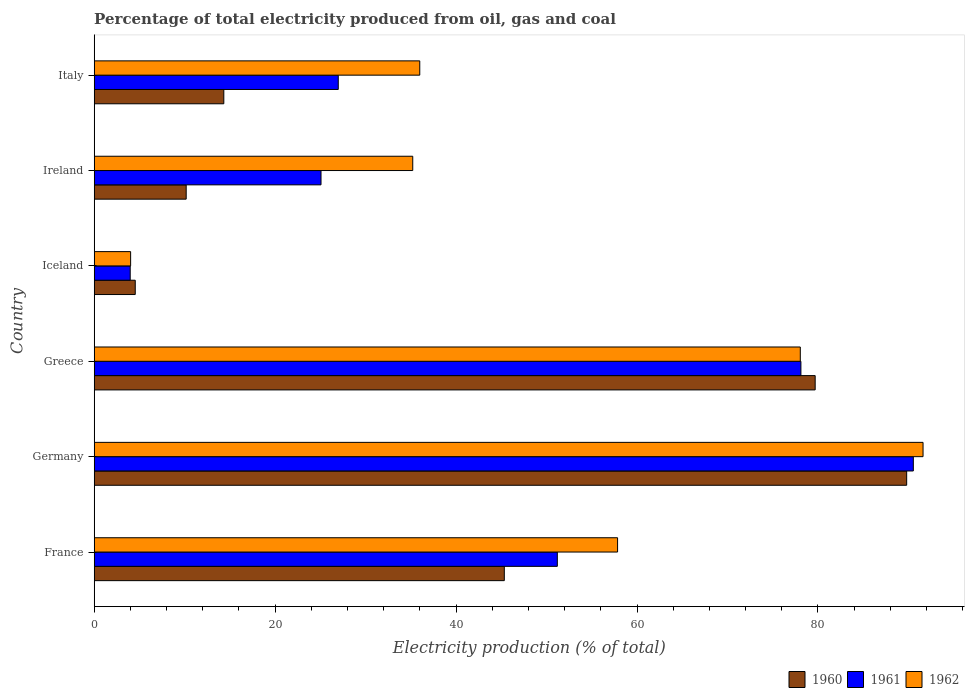How many groups of bars are there?
Keep it short and to the point. 6. Are the number of bars on each tick of the Y-axis equal?
Provide a short and direct response. Yes. How many bars are there on the 5th tick from the top?
Give a very brief answer. 3. How many bars are there on the 6th tick from the bottom?
Your response must be concise. 3. What is the label of the 1st group of bars from the top?
Your answer should be very brief. Italy. What is the electricity production in in 1962 in Ireland?
Provide a succinct answer. 35.21. Across all countries, what is the maximum electricity production in in 1961?
Provide a short and direct response. 90.54. Across all countries, what is the minimum electricity production in in 1961?
Your response must be concise. 3.98. In which country was the electricity production in in 1962 maximum?
Ensure brevity in your answer.  Germany. What is the total electricity production in in 1962 in the graph?
Your response must be concise. 302.74. What is the difference between the electricity production in in 1961 in France and that in Germany?
Keep it short and to the point. -39.35. What is the difference between the electricity production in in 1962 in Ireland and the electricity production in in 1961 in Germany?
Offer a terse response. -55.33. What is the average electricity production in in 1961 per country?
Provide a short and direct response. 45.98. What is the difference between the electricity production in in 1962 and electricity production in in 1960 in Iceland?
Your response must be concise. -0.51. In how many countries, is the electricity production in in 1962 greater than 52 %?
Your answer should be compact. 3. What is the ratio of the electricity production in in 1960 in France to that in Iceland?
Keep it short and to the point. 9.99. What is the difference between the highest and the second highest electricity production in in 1960?
Provide a succinct answer. 10.11. What is the difference between the highest and the lowest electricity production in in 1961?
Offer a terse response. 86.56. In how many countries, is the electricity production in in 1961 greater than the average electricity production in in 1961 taken over all countries?
Offer a very short reply. 3. Is it the case that in every country, the sum of the electricity production in in 1961 and electricity production in in 1962 is greater than the electricity production in in 1960?
Your response must be concise. Yes. Are all the bars in the graph horizontal?
Keep it short and to the point. Yes. What is the difference between two consecutive major ticks on the X-axis?
Ensure brevity in your answer.  20. Does the graph contain any zero values?
Offer a terse response. No. Where does the legend appear in the graph?
Provide a short and direct response. Bottom right. How many legend labels are there?
Provide a succinct answer. 3. What is the title of the graph?
Your answer should be compact. Percentage of total electricity produced from oil, gas and coal. Does "2005" appear as one of the legend labels in the graph?
Keep it short and to the point. No. What is the label or title of the X-axis?
Your answer should be very brief. Electricity production (% of total). What is the Electricity production (% of total) in 1960 in France?
Keep it short and to the point. 45.33. What is the Electricity production (% of total) in 1961 in France?
Your answer should be very brief. 51.19. What is the Electricity production (% of total) of 1962 in France?
Make the answer very short. 57.85. What is the Electricity production (% of total) of 1960 in Germany?
Offer a terse response. 89.81. What is the Electricity production (% of total) in 1961 in Germany?
Your response must be concise. 90.54. What is the Electricity production (% of total) in 1962 in Germany?
Keep it short and to the point. 91.62. What is the Electricity production (% of total) of 1960 in Greece?
Make the answer very short. 79.69. What is the Electricity production (% of total) in 1961 in Greece?
Give a very brief answer. 78.12. What is the Electricity production (% of total) of 1962 in Greece?
Provide a succinct answer. 78.05. What is the Electricity production (% of total) of 1960 in Iceland?
Offer a terse response. 4.54. What is the Electricity production (% of total) of 1961 in Iceland?
Make the answer very short. 3.98. What is the Electricity production (% of total) of 1962 in Iceland?
Provide a succinct answer. 4.03. What is the Electricity production (% of total) in 1960 in Ireland?
Offer a terse response. 10.17. What is the Electricity production (% of total) of 1961 in Ireland?
Provide a succinct answer. 25.07. What is the Electricity production (% of total) in 1962 in Ireland?
Provide a short and direct response. 35.21. What is the Electricity production (% of total) of 1960 in Italy?
Ensure brevity in your answer.  14.33. What is the Electricity production (% of total) of 1961 in Italy?
Offer a very short reply. 26.98. What is the Electricity production (% of total) in 1962 in Italy?
Your answer should be very brief. 35.99. Across all countries, what is the maximum Electricity production (% of total) in 1960?
Make the answer very short. 89.81. Across all countries, what is the maximum Electricity production (% of total) of 1961?
Offer a very short reply. 90.54. Across all countries, what is the maximum Electricity production (% of total) in 1962?
Give a very brief answer. 91.62. Across all countries, what is the minimum Electricity production (% of total) of 1960?
Your answer should be compact. 4.54. Across all countries, what is the minimum Electricity production (% of total) of 1961?
Provide a succinct answer. 3.98. Across all countries, what is the minimum Electricity production (% of total) of 1962?
Offer a terse response. 4.03. What is the total Electricity production (% of total) of 1960 in the graph?
Your answer should be compact. 243.87. What is the total Electricity production (% of total) in 1961 in the graph?
Give a very brief answer. 275.88. What is the total Electricity production (% of total) of 1962 in the graph?
Provide a short and direct response. 302.74. What is the difference between the Electricity production (% of total) in 1960 in France and that in Germany?
Keep it short and to the point. -44.48. What is the difference between the Electricity production (% of total) in 1961 in France and that in Germany?
Your response must be concise. -39.35. What is the difference between the Electricity production (% of total) of 1962 in France and that in Germany?
Your answer should be very brief. -33.77. What is the difference between the Electricity production (% of total) of 1960 in France and that in Greece?
Provide a succinct answer. -34.36. What is the difference between the Electricity production (% of total) of 1961 in France and that in Greece?
Give a very brief answer. -26.92. What is the difference between the Electricity production (% of total) of 1962 in France and that in Greece?
Provide a short and direct response. -20.2. What is the difference between the Electricity production (% of total) in 1960 in France and that in Iceland?
Provide a succinct answer. 40.8. What is the difference between the Electricity production (% of total) of 1961 in France and that in Iceland?
Your response must be concise. 47.21. What is the difference between the Electricity production (% of total) in 1962 in France and that in Iceland?
Your answer should be very brief. 53.83. What is the difference between the Electricity production (% of total) in 1960 in France and that in Ireland?
Your response must be concise. 35.16. What is the difference between the Electricity production (% of total) in 1961 in France and that in Ireland?
Ensure brevity in your answer.  26.12. What is the difference between the Electricity production (% of total) of 1962 in France and that in Ireland?
Offer a terse response. 22.64. What is the difference between the Electricity production (% of total) of 1960 in France and that in Italy?
Offer a very short reply. 31. What is the difference between the Electricity production (% of total) of 1961 in France and that in Italy?
Give a very brief answer. 24.21. What is the difference between the Electricity production (% of total) in 1962 in France and that in Italy?
Offer a very short reply. 21.86. What is the difference between the Electricity production (% of total) in 1960 in Germany and that in Greece?
Provide a succinct answer. 10.11. What is the difference between the Electricity production (% of total) in 1961 in Germany and that in Greece?
Offer a very short reply. 12.43. What is the difference between the Electricity production (% of total) of 1962 in Germany and that in Greece?
Your answer should be very brief. 13.57. What is the difference between the Electricity production (% of total) in 1960 in Germany and that in Iceland?
Your response must be concise. 85.27. What is the difference between the Electricity production (% of total) of 1961 in Germany and that in Iceland?
Keep it short and to the point. 86.56. What is the difference between the Electricity production (% of total) of 1962 in Germany and that in Iceland?
Make the answer very short. 87.59. What is the difference between the Electricity production (% of total) in 1960 in Germany and that in Ireland?
Give a very brief answer. 79.64. What is the difference between the Electricity production (% of total) in 1961 in Germany and that in Ireland?
Your answer should be very brief. 65.47. What is the difference between the Electricity production (% of total) in 1962 in Germany and that in Ireland?
Your answer should be very brief. 56.41. What is the difference between the Electricity production (% of total) of 1960 in Germany and that in Italy?
Make the answer very short. 75.48. What is the difference between the Electricity production (% of total) of 1961 in Germany and that in Italy?
Offer a terse response. 63.57. What is the difference between the Electricity production (% of total) of 1962 in Germany and that in Italy?
Give a very brief answer. 55.63. What is the difference between the Electricity production (% of total) of 1960 in Greece and that in Iceland?
Your answer should be very brief. 75.16. What is the difference between the Electricity production (% of total) in 1961 in Greece and that in Iceland?
Offer a terse response. 74.14. What is the difference between the Electricity production (% of total) in 1962 in Greece and that in Iceland?
Offer a very short reply. 74.02. What is the difference between the Electricity production (% of total) of 1960 in Greece and that in Ireland?
Offer a very short reply. 69.53. What is the difference between the Electricity production (% of total) in 1961 in Greece and that in Ireland?
Your response must be concise. 53.05. What is the difference between the Electricity production (% of total) in 1962 in Greece and that in Ireland?
Your answer should be compact. 42.84. What is the difference between the Electricity production (% of total) of 1960 in Greece and that in Italy?
Your response must be concise. 65.37. What is the difference between the Electricity production (% of total) in 1961 in Greece and that in Italy?
Your answer should be compact. 51.14. What is the difference between the Electricity production (% of total) in 1962 in Greece and that in Italy?
Give a very brief answer. 42.06. What is the difference between the Electricity production (% of total) in 1960 in Iceland and that in Ireland?
Make the answer very short. -5.63. What is the difference between the Electricity production (% of total) in 1961 in Iceland and that in Ireland?
Provide a succinct answer. -21.09. What is the difference between the Electricity production (% of total) of 1962 in Iceland and that in Ireland?
Your answer should be very brief. -31.19. What is the difference between the Electricity production (% of total) of 1960 in Iceland and that in Italy?
Your response must be concise. -9.79. What is the difference between the Electricity production (% of total) of 1961 in Iceland and that in Italy?
Provide a succinct answer. -23. What is the difference between the Electricity production (% of total) of 1962 in Iceland and that in Italy?
Make the answer very short. -31.96. What is the difference between the Electricity production (% of total) in 1960 in Ireland and that in Italy?
Your answer should be very brief. -4.16. What is the difference between the Electricity production (% of total) of 1961 in Ireland and that in Italy?
Your response must be concise. -1.91. What is the difference between the Electricity production (% of total) in 1962 in Ireland and that in Italy?
Offer a terse response. -0.78. What is the difference between the Electricity production (% of total) of 1960 in France and the Electricity production (% of total) of 1961 in Germany?
Make the answer very short. -45.21. What is the difference between the Electricity production (% of total) in 1960 in France and the Electricity production (% of total) in 1962 in Germany?
Give a very brief answer. -46.29. What is the difference between the Electricity production (% of total) of 1961 in France and the Electricity production (% of total) of 1962 in Germany?
Keep it short and to the point. -40.43. What is the difference between the Electricity production (% of total) of 1960 in France and the Electricity production (% of total) of 1961 in Greece?
Keep it short and to the point. -32.78. What is the difference between the Electricity production (% of total) of 1960 in France and the Electricity production (% of total) of 1962 in Greece?
Your answer should be compact. -32.72. What is the difference between the Electricity production (% of total) in 1961 in France and the Electricity production (% of total) in 1962 in Greece?
Offer a terse response. -26.86. What is the difference between the Electricity production (% of total) in 1960 in France and the Electricity production (% of total) in 1961 in Iceland?
Offer a terse response. 41.35. What is the difference between the Electricity production (% of total) of 1960 in France and the Electricity production (% of total) of 1962 in Iceland?
Provide a short and direct response. 41.31. What is the difference between the Electricity production (% of total) of 1961 in France and the Electricity production (% of total) of 1962 in Iceland?
Your answer should be compact. 47.17. What is the difference between the Electricity production (% of total) of 1960 in France and the Electricity production (% of total) of 1961 in Ireland?
Provide a short and direct response. 20.26. What is the difference between the Electricity production (% of total) of 1960 in France and the Electricity production (% of total) of 1962 in Ireland?
Your response must be concise. 10.12. What is the difference between the Electricity production (% of total) of 1961 in France and the Electricity production (% of total) of 1962 in Ireland?
Provide a succinct answer. 15.98. What is the difference between the Electricity production (% of total) in 1960 in France and the Electricity production (% of total) in 1961 in Italy?
Your answer should be very brief. 18.35. What is the difference between the Electricity production (% of total) in 1960 in France and the Electricity production (% of total) in 1962 in Italy?
Provide a short and direct response. 9.35. What is the difference between the Electricity production (% of total) of 1961 in France and the Electricity production (% of total) of 1962 in Italy?
Offer a very short reply. 15.21. What is the difference between the Electricity production (% of total) in 1960 in Germany and the Electricity production (% of total) in 1961 in Greece?
Keep it short and to the point. 11.69. What is the difference between the Electricity production (% of total) of 1960 in Germany and the Electricity production (% of total) of 1962 in Greece?
Offer a terse response. 11.76. What is the difference between the Electricity production (% of total) of 1961 in Germany and the Electricity production (% of total) of 1962 in Greece?
Provide a succinct answer. 12.49. What is the difference between the Electricity production (% of total) in 1960 in Germany and the Electricity production (% of total) in 1961 in Iceland?
Provide a succinct answer. 85.83. What is the difference between the Electricity production (% of total) of 1960 in Germany and the Electricity production (% of total) of 1962 in Iceland?
Your answer should be very brief. 85.78. What is the difference between the Electricity production (% of total) in 1961 in Germany and the Electricity production (% of total) in 1962 in Iceland?
Offer a terse response. 86.52. What is the difference between the Electricity production (% of total) in 1960 in Germany and the Electricity production (% of total) in 1961 in Ireland?
Ensure brevity in your answer.  64.74. What is the difference between the Electricity production (% of total) in 1960 in Germany and the Electricity production (% of total) in 1962 in Ireland?
Ensure brevity in your answer.  54.6. What is the difference between the Electricity production (% of total) in 1961 in Germany and the Electricity production (% of total) in 1962 in Ireland?
Make the answer very short. 55.33. What is the difference between the Electricity production (% of total) of 1960 in Germany and the Electricity production (% of total) of 1961 in Italy?
Give a very brief answer. 62.83. What is the difference between the Electricity production (% of total) of 1960 in Germany and the Electricity production (% of total) of 1962 in Italy?
Your answer should be very brief. 53.82. What is the difference between the Electricity production (% of total) of 1961 in Germany and the Electricity production (% of total) of 1962 in Italy?
Keep it short and to the point. 54.56. What is the difference between the Electricity production (% of total) in 1960 in Greece and the Electricity production (% of total) in 1961 in Iceland?
Ensure brevity in your answer.  75.71. What is the difference between the Electricity production (% of total) of 1960 in Greece and the Electricity production (% of total) of 1962 in Iceland?
Provide a short and direct response. 75.67. What is the difference between the Electricity production (% of total) in 1961 in Greece and the Electricity production (% of total) in 1962 in Iceland?
Give a very brief answer. 74.09. What is the difference between the Electricity production (% of total) of 1960 in Greece and the Electricity production (% of total) of 1961 in Ireland?
Offer a terse response. 54.62. What is the difference between the Electricity production (% of total) of 1960 in Greece and the Electricity production (% of total) of 1962 in Ireland?
Offer a terse response. 44.48. What is the difference between the Electricity production (% of total) of 1961 in Greece and the Electricity production (% of total) of 1962 in Ireland?
Make the answer very short. 42.91. What is the difference between the Electricity production (% of total) of 1960 in Greece and the Electricity production (% of total) of 1961 in Italy?
Provide a succinct answer. 52.72. What is the difference between the Electricity production (% of total) of 1960 in Greece and the Electricity production (% of total) of 1962 in Italy?
Provide a succinct answer. 43.71. What is the difference between the Electricity production (% of total) of 1961 in Greece and the Electricity production (% of total) of 1962 in Italy?
Your answer should be compact. 42.13. What is the difference between the Electricity production (% of total) in 1960 in Iceland and the Electricity production (% of total) in 1961 in Ireland?
Give a very brief answer. -20.53. What is the difference between the Electricity production (% of total) in 1960 in Iceland and the Electricity production (% of total) in 1962 in Ireland?
Give a very brief answer. -30.67. What is the difference between the Electricity production (% of total) in 1961 in Iceland and the Electricity production (% of total) in 1962 in Ireland?
Keep it short and to the point. -31.23. What is the difference between the Electricity production (% of total) of 1960 in Iceland and the Electricity production (% of total) of 1961 in Italy?
Your answer should be compact. -22.44. What is the difference between the Electricity production (% of total) in 1960 in Iceland and the Electricity production (% of total) in 1962 in Italy?
Give a very brief answer. -31.45. What is the difference between the Electricity production (% of total) of 1961 in Iceland and the Electricity production (% of total) of 1962 in Italy?
Give a very brief answer. -32.01. What is the difference between the Electricity production (% of total) of 1960 in Ireland and the Electricity production (% of total) of 1961 in Italy?
Keep it short and to the point. -16.81. What is the difference between the Electricity production (% of total) of 1960 in Ireland and the Electricity production (% of total) of 1962 in Italy?
Provide a short and direct response. -25.82. What is the difference between the Electricity production (% of total) in 1961 in Ireland and the Electricity production (% of total) in 1962 in Italy?
Make the answer very short. -10.92. What is the average Electricity production (% of total) in 1960 per country?
Give a very brief answer. 40.64. What is the average Electricity production (% of total) in 1961 per country?
Make the answer very short. 45.98. What is the average Electricity production (% of total) in 1962 per country?
Keep it short and to the point. 50.46. What is the difference between the Electricity production (% of total) in 1960 and Electricity production (% of total) in 1961 in France?
Provide a short and direct response. -5.86. What is the difference between the Electricity production (% of total) of 1960 and Electricity production (% of total) of 1962 in France?
Provide a short and direct response. -12.52. What is the difference between the Electricity production (% of total) in 1961 and Electricity production (% of total) in 1962 in France?
Offer a terse response. -6.66. What is the difference between the Electricity production (% of total) of 1960 and Electricity production (% of total) of 1961 in Germany?
Your answer should be compact. -0.74. What is the difference between the Electricity production (% of total) in 1960 and Electricity production (% of total) in 1962 in Germany?
Give a very brief answer. -1.81. What is the difference between the Electricity production (% of total) in 1961 and Electricity production (% of total) in 1962 in Germany?
Your answer should be very brief. -1.07. What is the difference between the Electricity production (% of total) in 1960 and Electricity production (% of total) in 1961 in Greece?
Ensure brevity in your answer.  1.58. What is the difference between the Electricity production (% of total) of 1960 and Electricity production (% of total) of 1962 in Greece?
Your answer should be very brief. 1.64. What is the difference between the Electricity production (% of total) in 1961 and Electricity production (% of total) in 1962 in Greece?
Offer a terse response. 0.07. What is the difference between the Electricity production (% of total) of 1960 and Electricity production (% of total) of 1961 in Iceland?
Provide a short and direct response. 0.56. What is the difference between the Electricity production (% of total) of 1960 and Electricity production (% of total) of 1962 in Iceland?
Offer a very short reply. 0.51. What is the difference between the Electricity production (% of total) of 1961 and Electricity production (% of total) of 1962 in Iceland?
Provide a succinct answer. -0.05. What is the difference between the Electricity production (% of total) in 1960 and Electricity production (% of total) in 1961 in Ireland?
Your answer should be compact. -14.9. What is the difference between the Electricity production (% of total) in 1960 and Electricity production (% of total) in 1962 in Ireland?
Ensure brevity in your answer.  -25.04. What is the difference between the Electricity production (% of total) of 1961 and Electricity production (% of total) of 1962 in Ireland?
Provide a succinct answer. -10.14. What is the difference between the Electricity production (% of total) of 1960 and Electricity production (% of total) of 1961 in Italy?
Provide a succinct answer. -12.65. What is the difference between the Electricity production (% of total) in 1960 and Electricity production (% of total) in 1962 in Italy?
Keep it short and to the point. -21.66. What is the difference between the Electricity production (% of total) in 1961 and Electricity production (% of total) in 1962 in Italy?
Ensure brevity in your answer.  -9.01. What is the ratio of the Electricity production (% of total) of 1960 in France to that in Germany?
Offer a terse response. 0.5. What is the ratio of the Electricity production (% of total) of 1961 in France to that in Germany?
Provide a succinct answer. 0.57. What is the ratio of the Electricity production (% of total) of 1962 in France to that in Germany?
Your answer should be compact. 0.63. What is the ratio of the Electricity production (% of total) in 1960 in France to that in Greece?
Offer a very short reply. 0.57. What is the ratio of the Electricity production (% of total) of 1961 in France to that in Greece?
Make the answer very short. 0.66. What is the ratio of the Electricity production (% of total) of 1962 in France to that in Greece?
Your answer should be very brief. 0.74. What is the ratio of the Electricity production (% of total) in 1960 in France to that in Iceland?
Ensure brevity in your answer.  9.99. What is the ratio of the Electricity production (% of total) of 1961 in France to that in Iceland?
Offer a very short reply. 12.86. What is the ratio of the Electricity production (% of total) in 1962 in France to that in Iceland?
Your answer should be compact. 14.37. What is the ratio of the Electricity production (% of total) in 1960 in France to that in Ireland?
Offer a very short reply. 4.46. What is the ratio of the Electricity production (% of total) of 1961 in France to that in Ireland?
Offer a terse response. 2.04. What is the ratio of the Electricity production (% of total) of 1962 in France to that in Ireland?
Offer a very short reply. 1.64. What is the ratio of the Electricity production (% of total) in 1960 in France to that in Italy?
Offer a very short reply. 3.16. What is the ratio of the Electricity production (% of total) in 1961 in France to that in Italy?
Ensure brevity in your answer.  1.9. What is the ratio of the Electricity production (% of total) in 1962 in France to that in Italy?
Give a very brief answer. 1.61. What is the ratio of the Electricity production (% of total) of 1960 in Germany to that in Greece?
Your answer should be very brief. 1.13. What is the ratio of the Electricity production (% of total) in 1961 in Germany to that in Greece?
Provide a succinct answer. 1.16. What is the ratio of the Electricity production (% of total) of 1962 in Germany to that in Greece?
Your answer should be very brief. 1.17. What is the ratio of the Electricity production (% of total) in 1960 in Germany to that in Iceland?
Give a very brief answer. 19.79. What is the ratio of the Electricity production (% of total) of 1961 in Germany to that in Iceland?
Your response must be concise. 22.75. What is the ratio of the Electricity production (% of total) in 1962 in Germany to that in Iceland?
Ensure brevity in your answer.  22.76. What is the ratio of the Electricity production (% of total) of 1960 in Germany to that in Ireland?
Make the answer very short. 8.83. What is the ratio of the Electricity production (% of total) of 1961 in Germany to that in Ireland?
Your answer should be compact. 3.61. What is the ratio of the Electricity production (% of total) in 1962 in Germany to that in Ireland?
Offer a very short reply. 2.6. What is the ratio of the Electricity production (% of total) of 1960 in Germany to that in Italy?
Your answer should be compact. 6.27. What is the ratio of the Electricity production (% of total) in 1961 in Germany to that in Italy?
Make the answer very short. 3.36. What is the ratio of the Electricity production (% of total) of 1962 in Germany to that in Italy?
Your answer should be very brief. 2.55. What is the ratio of the Electricity production (% of total) of 1960 in Greece to that in Iceland?
Keep it short and to the point. 17.56. What is the ratio of the Electricity production (% of total) of 1961 in Greece to that in Iceland?
Offer a very short reply. 19.63. What is the ratio of the Electricity production (% of total) of 1962 in Greece to that in Iceland?
Your answer should be compact. 19.39. What is the ratio of the Electricity production (% of total) of 1960 in Greece to that in Ireland?
Offer a terse response. 7.84. What is the ratio of the Electricity production (% of total) in 1961 in Greece to that in Ireland?
Provide a succinct answer. 3.12. What is the ratio of the Electricity production (% of total) of 1962 in Greece to that in Ireland?
Make the answer very short. 2.22. What is the ratio of the Electricity production (% of total) of 1960 in Greece to that in Italy?
Ensure brevity in your answer.  5.56. What is the ratio of the Electricity production (% of total) of 1961 in Greece to that in Italy?
Keep it short and to the point. 2.9. What is the ratio of the Electricity production (% of total) of 1962 in Greece to that in Italy?
Your answer should be very brief. 2.17. What is the ratio of the Electricity production (% of total) of 1960 in Iceland to that in Ireland?
Your answer should be compact. 0.45. What is the ratio of the Electricity production (% of total) in 1961 in Iceland to that in Ireland?
Offer a very short reply. 0.16. What is the ratio of the Electricity production (% of total) in 1962 in Iceland to that in Ireland?
Your answer should be very brief. 0.11. What is the ratio of the Electricity production (% of total) in 1960 in Iceland to that in Italy?
Your response must be concise. 0.32. What is the ratio of the Electricity production (% of total) of 1961 in Iceland to that in Italy?
Provide a succinct answer. 0.15. What is the ratio of the Electricity production (% of total) of 1962 in Iceland to that in Italy?
Your answer should be very brief. 0.11. What is the ratio of the Electricity production (% of total) in 1960 in Ireland to that in Italy?
Make the answer very short. 0.71. What is the ratio of the Electricity production (% of total) of 1961 in Ireland to that in Italy?
Offer a very short reply. 0.93. What is the ratio of the Electricity production (% of total) in 1962 in Ireland to that in Italy?
Offer a very short reply. 0.98. What is the difference between the highest and the second highest Electricity production (% of total) in 1960?
Your response must be concise. 10.11. What is the difference between the highest and the second highest Electricity production (% of total) in 1961?
Give a very brief answer. 12.43. What is the difference between the highest and the second highest Electricity production (% of total) in 1962?
Your response must be concise. 13.57. What is the difference between the highest and the lowest Electricity production (% of total) of 1960?
Offer a very short reply. 85.27. What is the difference between the highest and the lowest Electricity production (% of total) of 1961?
Your answer should be very brief. 86.56. What is the difference between the highest and the lowest Electricity production (% of total) of 1962?
Ensure brevity in your answer.  87.59. 